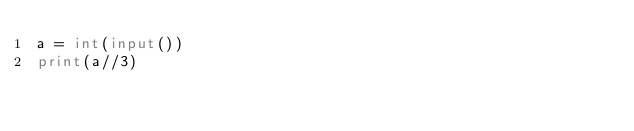<code> <loc_0><loc_0><loc_500><loc_500><_Python_>a = int(input())
print(a//3)</code> 